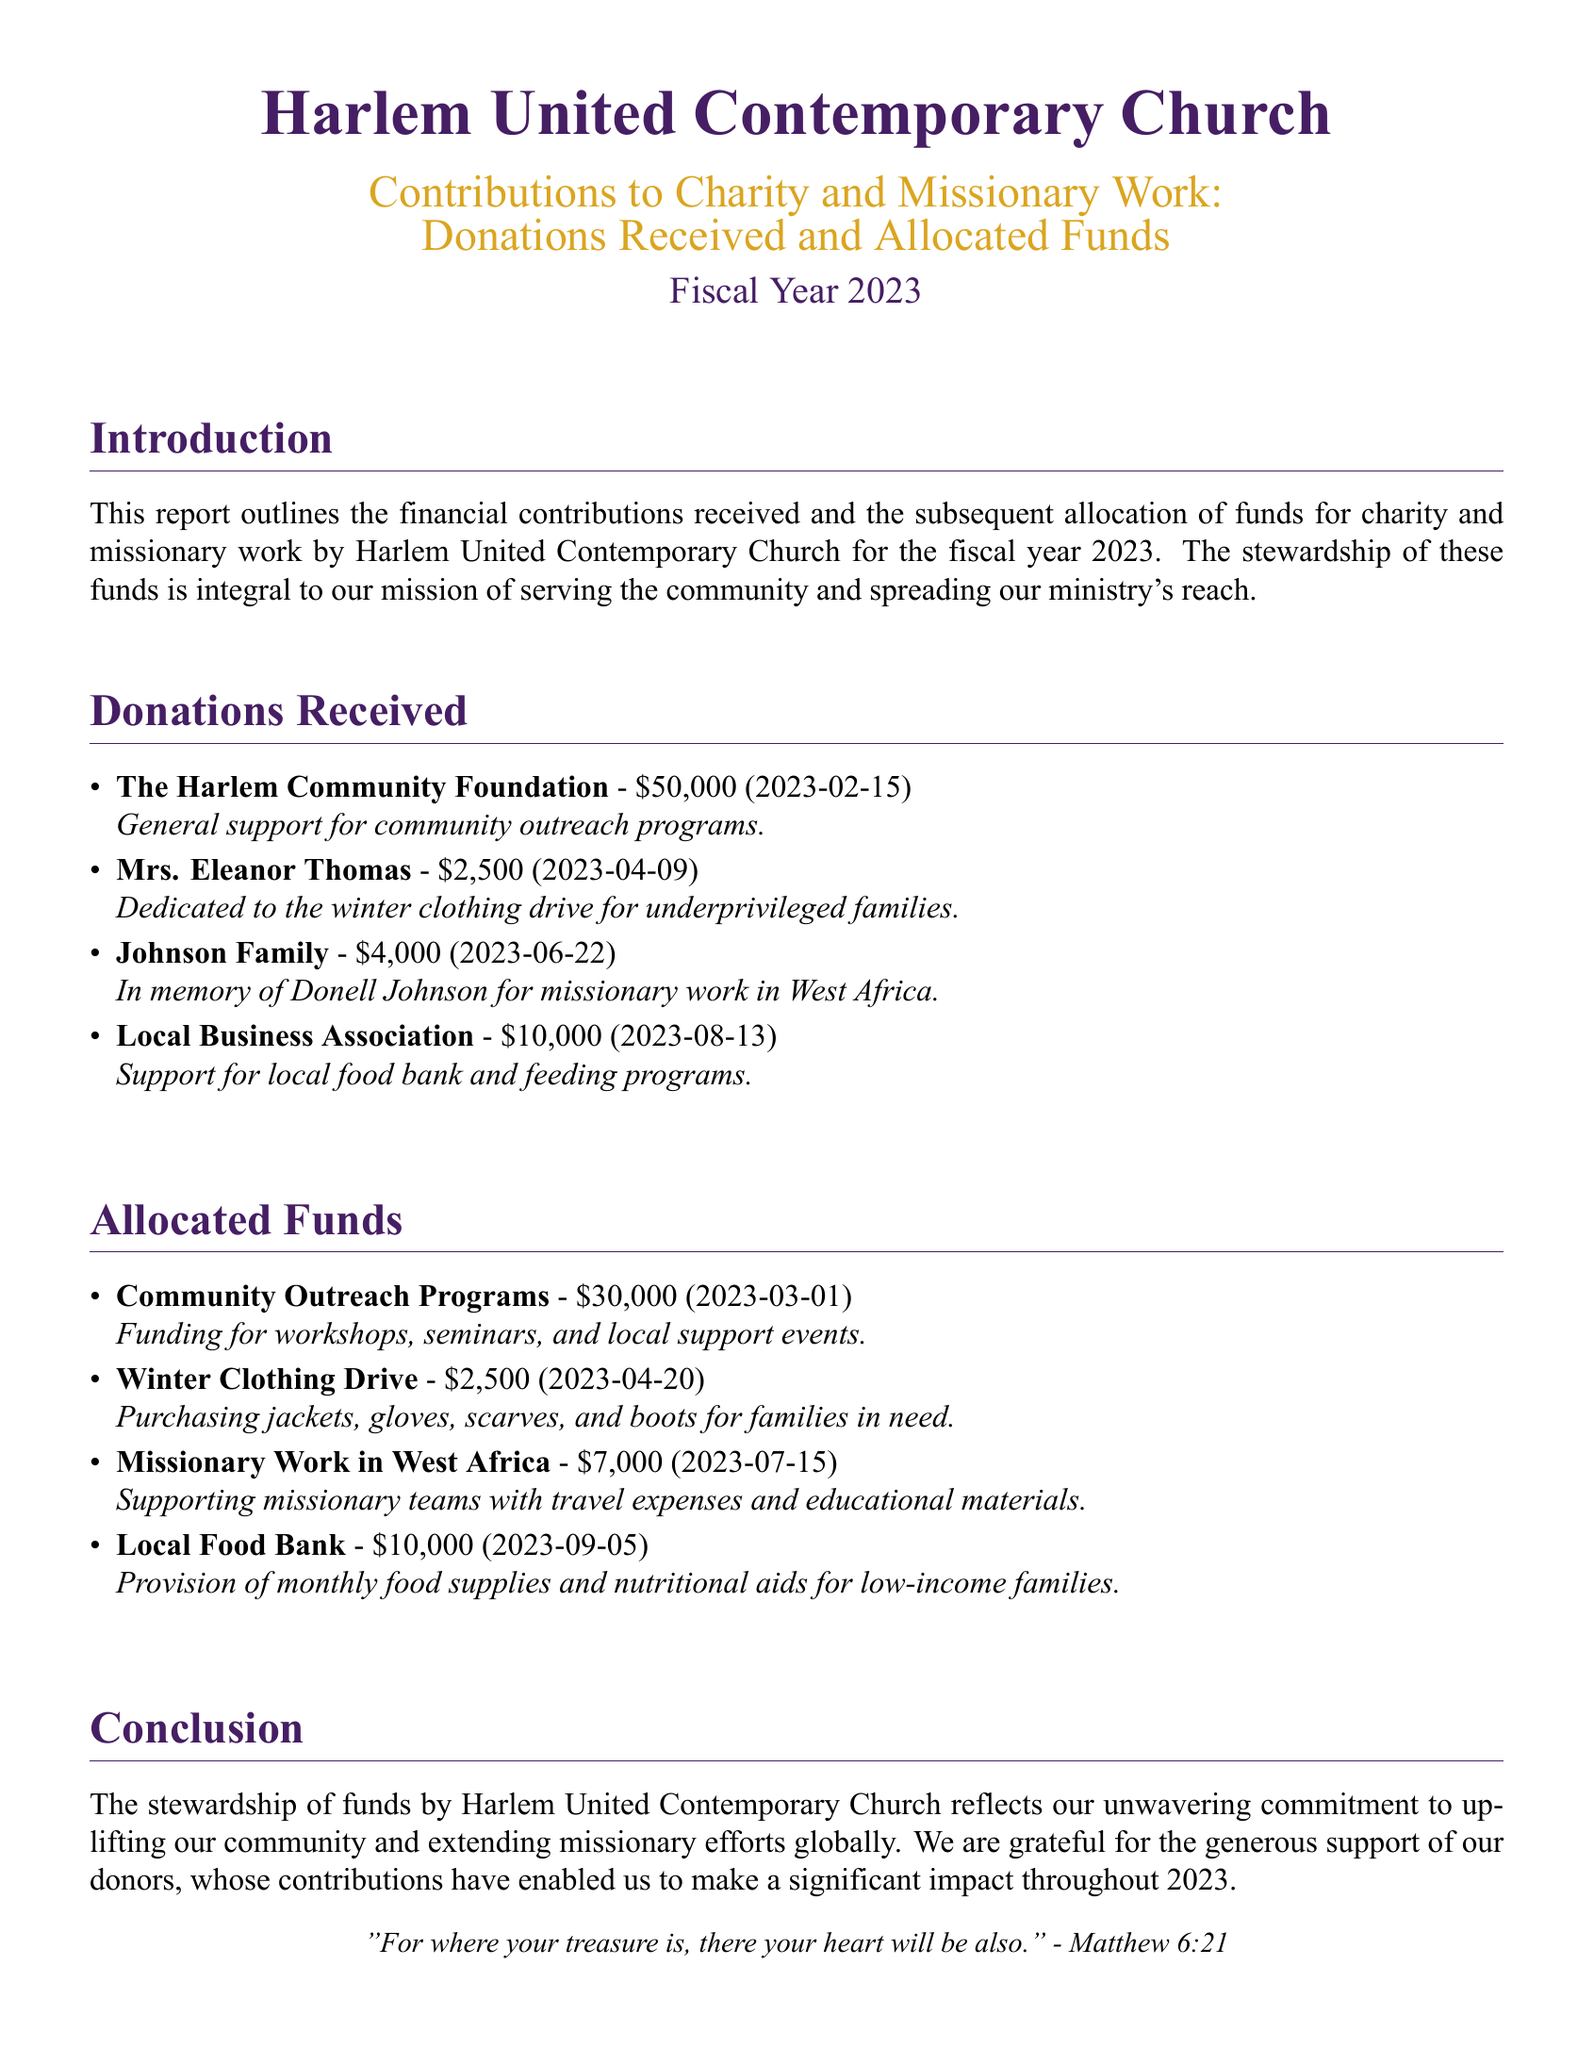What is the total amount of donations received? The total amount of donations is the sum of all donations received in the document, which is $50,000 + $2,500 + $4,000 + $10,000 = $66,500.
Answer: $66,500 What was allocated for Community Outreach Programs? The document states that $30,000 was allocated for Community Outreach Programs.
Answer: $30,000 Who donated in memory of Donell Johnson? The Johnson Family is mentioned as the donor in memory of Donell Johnson for missionary work.
Answer: Johnson Family What is the date of the last listed donation? The last donation listed is from the Local Business Association on 2023-08-13.
Answer: 2023-08-13 How much was spent on the Winter Clothing Drive? The funds allocated for the Winter Clothing Drive totaled $2,500.
Answer: $2,500 What is the purpose of the donation from Mrs. Eleanor Thomas? The purpose of Mrs. Eleanor Thomas' donation is for the winter clothing drive for underprivileged families.
Answer: Winter clothing drive for underprivileged families What is the amount allocated for the Local Food Bank? The Local Food Bank received an allocation of $10,000 according to the document.
Answer: $10,000 Which program received the highest allocation? The Community Outreach Programs received the highest allocation of $30,000.
Answer: Community Outreach Programs What date was the funding for the Missionary Work in West Africa allocated? The funding for Missionary Work in West Africa was allocated on 2023-07-15.
Answer: 2023-07-15 